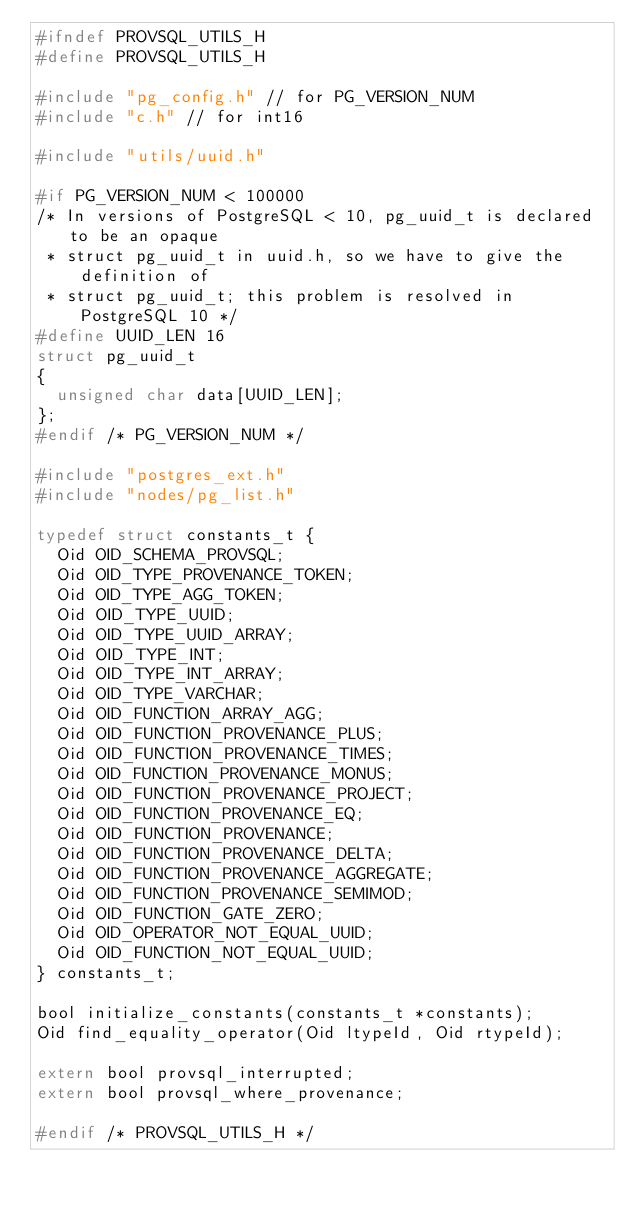Convert code to text. <code><loc_0><loc_0><loc_500><loc_500><_C_>#ifndef PROVSQL_UTILS_H
#define PROVSQL_UTILS_H

#include "pg_config.h" // for PG_VERSION_NUM
#include "c.h" // for int16

#include "utils/uuid.h"

#if PG_VERSION_NUM < 100000
/* In versions of PostgreSQL < 10, pg_uuid_t is declared to be an opaque
 * struct pg_uuid_t in uuid.h, so we have to give the definition of
 * struct pg_uuid_t; this problem is resolved in PostgreSQL 10 */
#define UUID_LEN 16
struct pg_uuid_t
{
  unsigned char data[UUID_LEN];
};
#endif /* PG_VERSION_NUM */

#include "postgres_ext.h"
#include "nodes/pg_list.h"

typedef struct constants_t {
  Oid OID_SCHEMA_PROVSQL;
  Oid OID_TYPE_PROVENANCE_TOKEN;
  Oid OID_TYPE_AGG_TOKEN;
  Oid OID_TYPE_UUID;
  Oid OID_TYPE_UUID_ARRAY;
  Oid OID_TYPE_INT;
  Oid OID_TYPE_INT_ARRAY;
  Oid OID_TYPE_VARCHAR;
  Oid OID_FUNCTION_ARRAY_AGG;
  Oid OID_FUNCTION_PROVENANCE_PLUS;
  Oid OID_FUNCTION_PROVENANCE_TIMES;
  Oid OID_FUNCTION_PROVENANCE_MONUS;
  Oid OID_FUNCTION_PROVENANCE_PROJECT;
  Oid OID_FUNCTION_PROVENANCE_EQ;
  Oid OID_FUNCTION_PROVENANCE;
  Oid OID_FUNCTION_PROVENANCE_DELTA;
  Oid OID_FUNCTION_PROVENANCE_AGGREGATE;
  Oid OID_FUNCTION_PROVENANCE_SEMIMOD;
  Oid OID_FUNCTION_GATE_ZERO;
  Oid OID_OPERATOR_NOT_EQUAL_UUID;
  Oid OID_FUNCTION_NOT_EQUAL_UUID;
} constants_t;

bool initialize_constants(constants_t *constants);
Oid find_equality_operator(Oid ltypeId, Oid rtypeId);

extern bool provsql_interrupted;
extern bool provsql_where_provenance;

#endif /* PROVSQL_UTILS_H */
</code> 